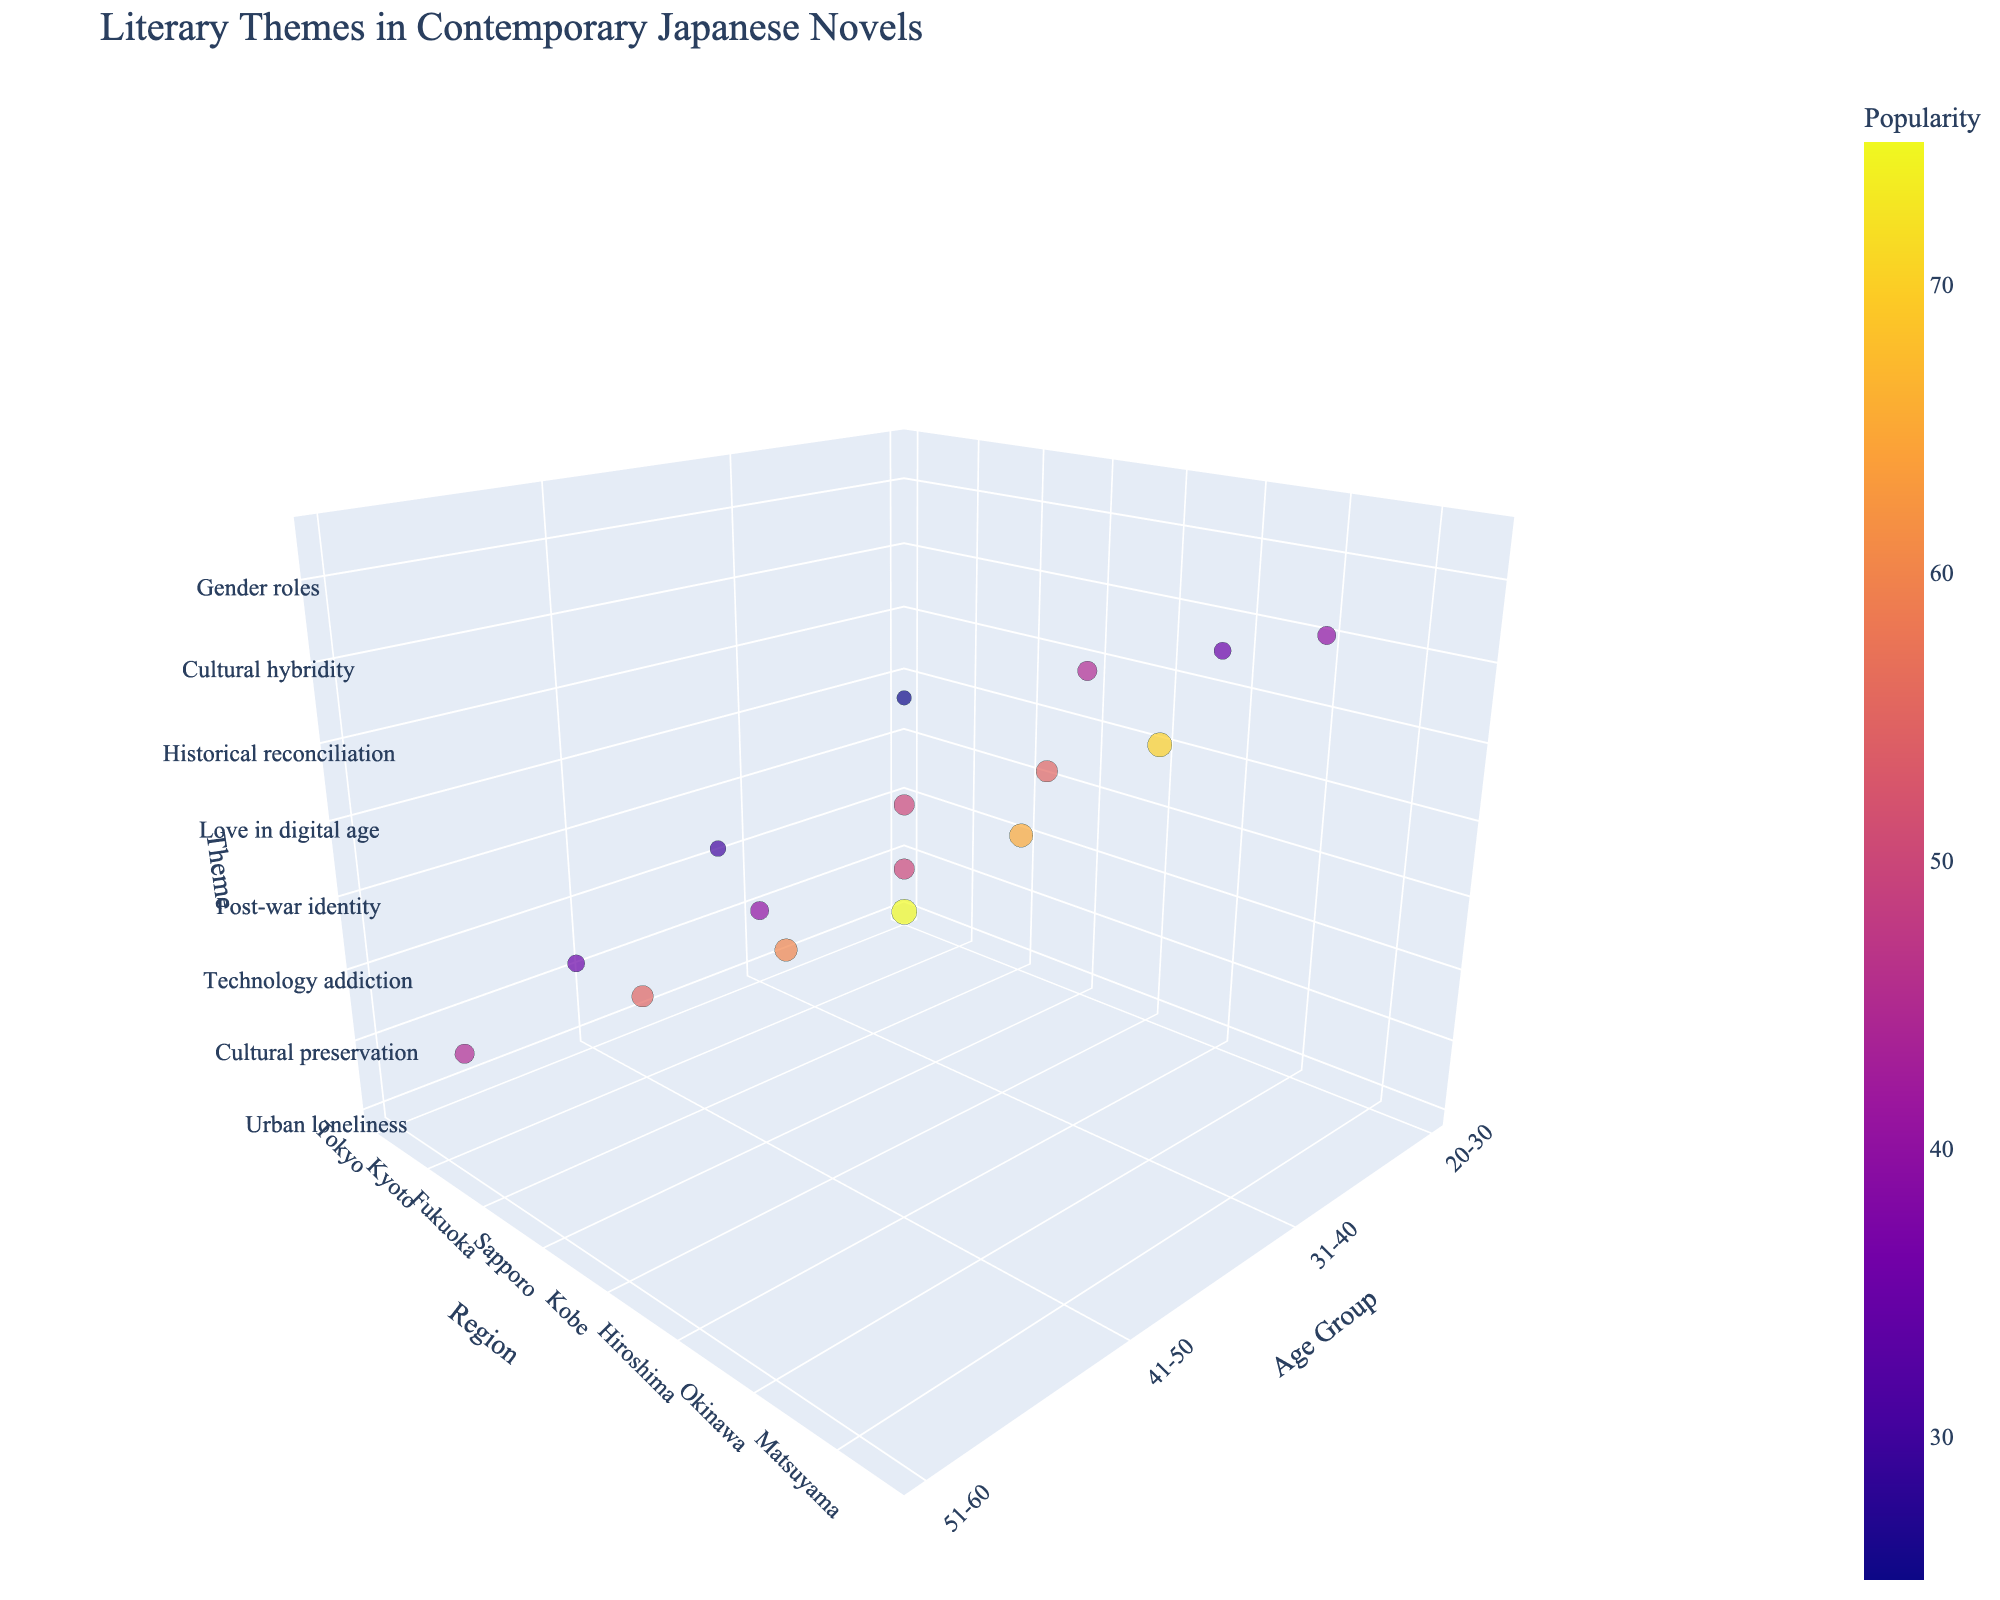What is the title of the figure? The title of the figure is usually located at the top. In this case, it's "Literary Themes in Contemporary Japanese Novels".
Answer: Literary Themes in Contemporary Japanese Novels What age group in Tokyo has the highest popularity for a theme, and what is the theme? Look at the bubbles in Tokyo across different age groups. The age group 20-30 in Tokyo has the largest bubble size represents higher popularity, and the theme is "Urban loneliness".
Answer: 20-30, Urban loneliness Which region shows the theme "Nature and spirituality," and what is its popularity? Locate the bubble with the theme "Nature and spirituality" by hovering over it. It’s in the region Hokkaido and has a popularity of 45.
Answer: Hokkaido, 45 Compare the popularity of the themes "Historical reconciliation" and "Intergenerational conflict." Which one is more popular and by how much? Locate the bubbles with "Historical reconciliation" and "Intergenerational conflict". "Historical reconciliation" has a popularity of 50, and "Intergenerational conflict" has 25. The difference is 50 - 25 = 25.
Answer: Historical reconciliation, by 25 What is the average popularity of the themes in the age group 31-40? Identify bubbles within the 31-40 age group and note their popularity values: 60, 50, 55, 35. Calculate the average (60 + 50 + 55 + 35) / 4 = 50.
Answer: 50 Which region has the least popular theme, and what is the theme? Locate the smallest bubble to determine the least popular theme and its region. The smallest bubble is in Niigata with the theme "Intergenerational conflict" and a popularity of 25.
Answer: Niigata, Intergenerational conflict What are the regions represented in the age group 20-30, and which one has the lowest popularity? List the regions in the 20-30 age group (Tokyo, Fukuoka, Kobe, Okinawa) and compare their popularity values: 75, 65, 70, 40. The lowest is Okinawa with 40.
Answer: Okinawa Which two regions in the age group 41-50 have the closest popularity? Identify and compare the bubbles in the 41-50 age group: Kyoto (55), Sapporo (40), Hiroshima (50), Matsuyama (45). Kyoto and Hiroshima are closest with 55 and 50, a difference of 5.
Answer: Kyoto and Hiroshima Which theme in the region of Osaka has been addressed, and what is its popularity? Look at the bubbles associated with Osaka. The theme "Family dynamics" is given and has a popularity of 60.
Answer: Family dynamics, 60 